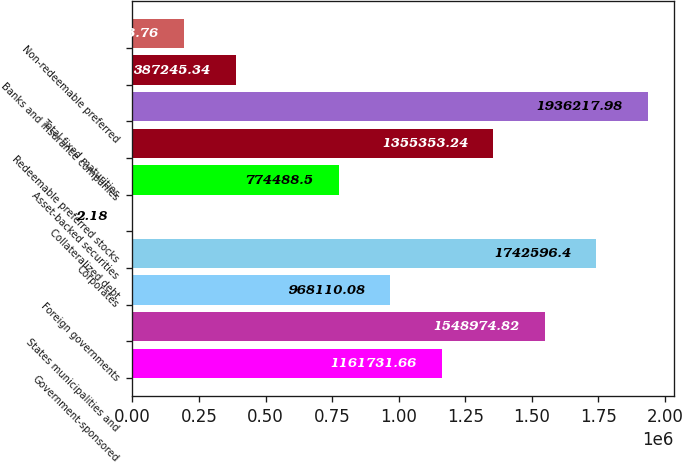Convert chart to OTSL. <chart><loc_0><loc_0><loc_500><loc_500><bar_chart><fcel>Government-sponsored<fcel>States municipalities and<fcel>Foreign governments<fcel>Corporates<fcel>Collateralized debt<fcel>Asset-backed securities<fcel>Redeemable preferred stocks<fcel>Total fixed maturities<fcel>Banks and insurance companies<fcel>Non-redeemable preferred<nl><fcel>1.16173e+06<fcel>1.54897e+06<fcel>968110<fcel>1.7426e+06<fcel>2.18<fcel>774488<fcel>1.35535e+06<fcel>1.93622e+06<fcel>387245<fcel>193624<nl></chart> 